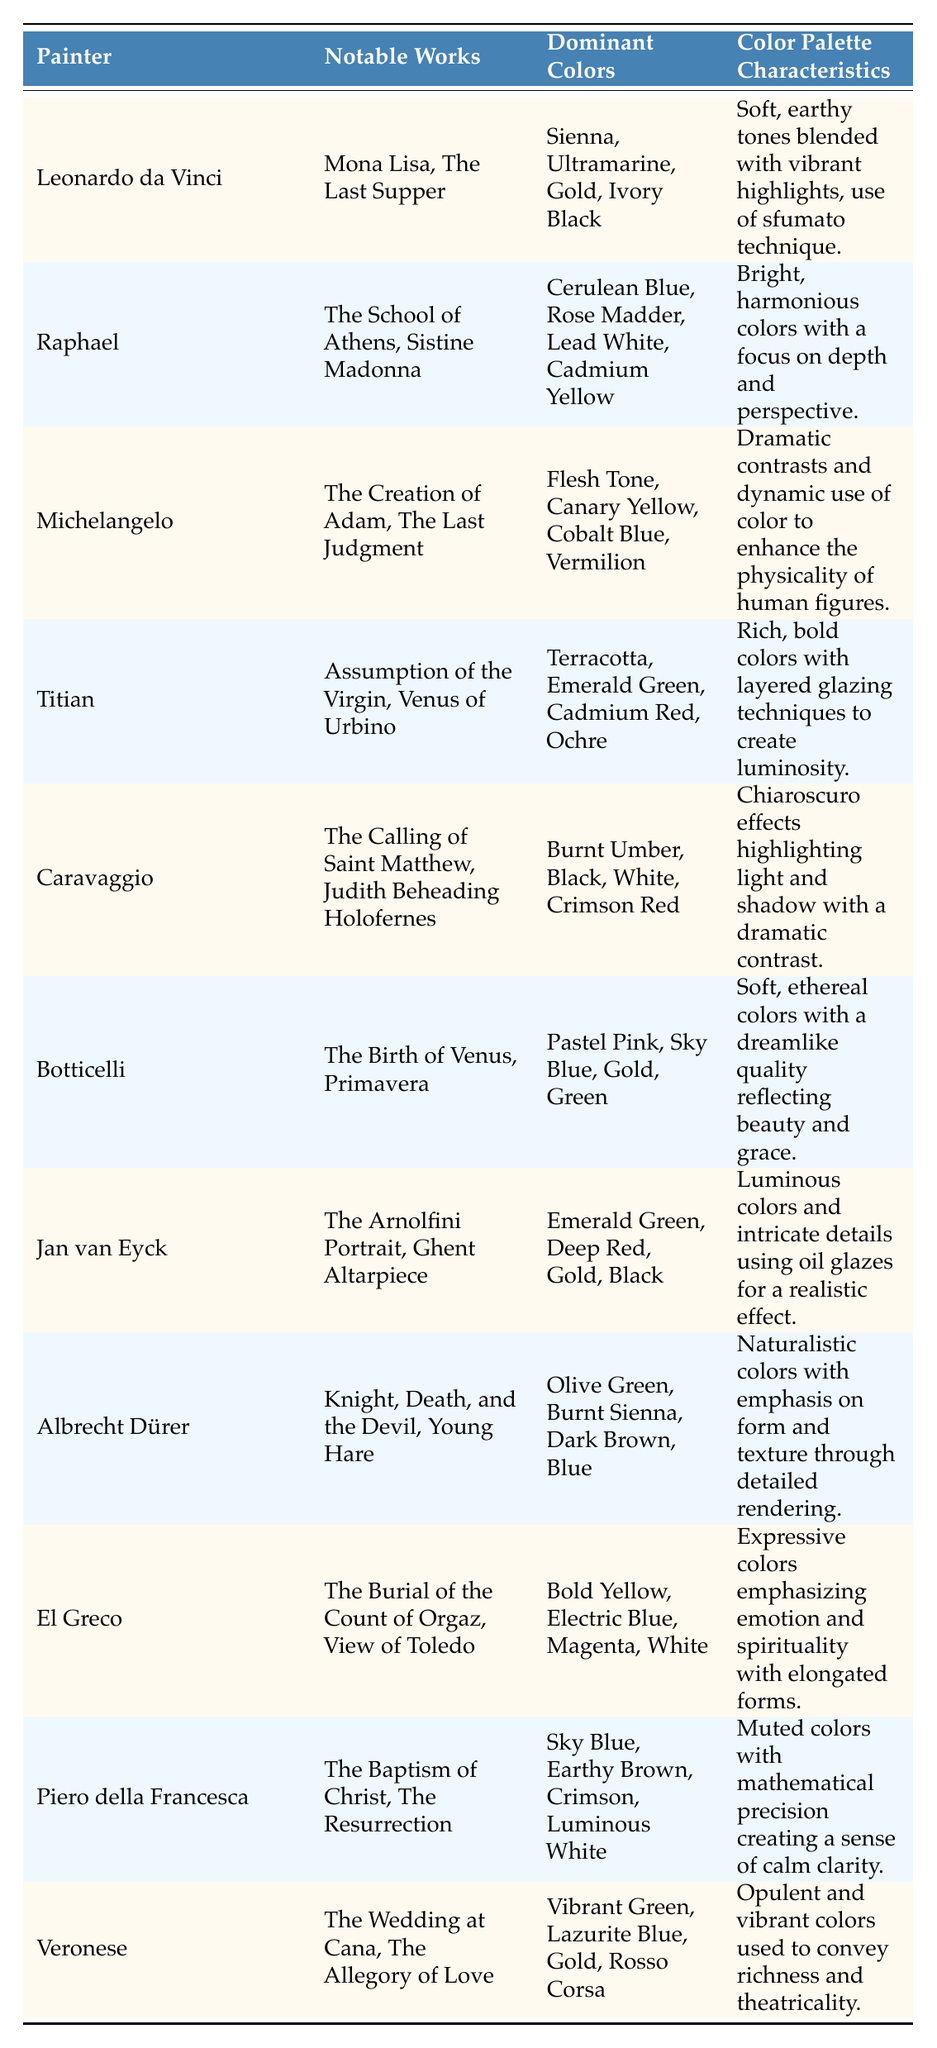What dominant colors are used by Michelangelo? According to the table, the dominant colors used by Michelangelo are Flesh Tone, Canary Yellow, Cobalt Blue, and Vermilion.
Answer: Flesh Tone, Canary Yellow, Cobalt Blue, Vermilion Which painter is known for the use of sfumato technique? The table states that Leonardo da Vinci is known for using the sfumato technique.
Answer: Leonardo da Vinci What are the notable works of Botticelli? The notable works of Botticelli listed in the table are The Birth of Venus and Primavera.
Answer: The Birth of Venus, Primavera How many colors are listed for Titian? The table lists four dominant colors for Titian: Terracotta, Emerald Green, Cadmium Red, and Ochre.
Answer: Four Which painter used the color Rose Madder? The table indicates that Raphael used the color Rose Madder.
Answer: Raphael Is Caravaggio known for using pastel colors? According to the information, Caravaggio is not known for using pastel colors, as his dominant colors include Burnt Umber, Black, White, and Crimson Red.
Answer: No Which painter's palette features earthy brown tones? The table shows that Piero della Francesca uses earthy brown tones among his colors.
Answer: Piero della Francesca How does the color palette of El Greco differ from that of Leonardo da Vinci? El Greco's palette includes expressive colors like Bold Yellow, Electric Blue, and Magenta, while Leonardo's colors are softer and earthier, such as Sienna and Ultramarine.
Answer: El Greco's is expressive; Leonardo's is softer and earthier What would be the average number of dominant colors across the listed painters? There are 11 painters, and each has four dominant colors listed. By adding the colors (4 x 11 = 44) and then dividing by 11 (44/11 = 4), the average number of dominant colors per painter is 4.
Answer: 4 Which painter used gold as one of their dominant colors? Both Leonardo da Vinci and Jan van Eyck are listed as using gold in their palettes according to the table.
Answer: Leonardo da Vinci, Jan van Eyck What is the contrasting style difference between Caravaggio and Botticelli? Caravaggio's style emphasizes chiaroscuro with dramatic contrasts, while Botticelli uses soft and ethereal colors, resulting in a dreamlike quality.
Answer: Chiaroscuro vs. ethereal softness 